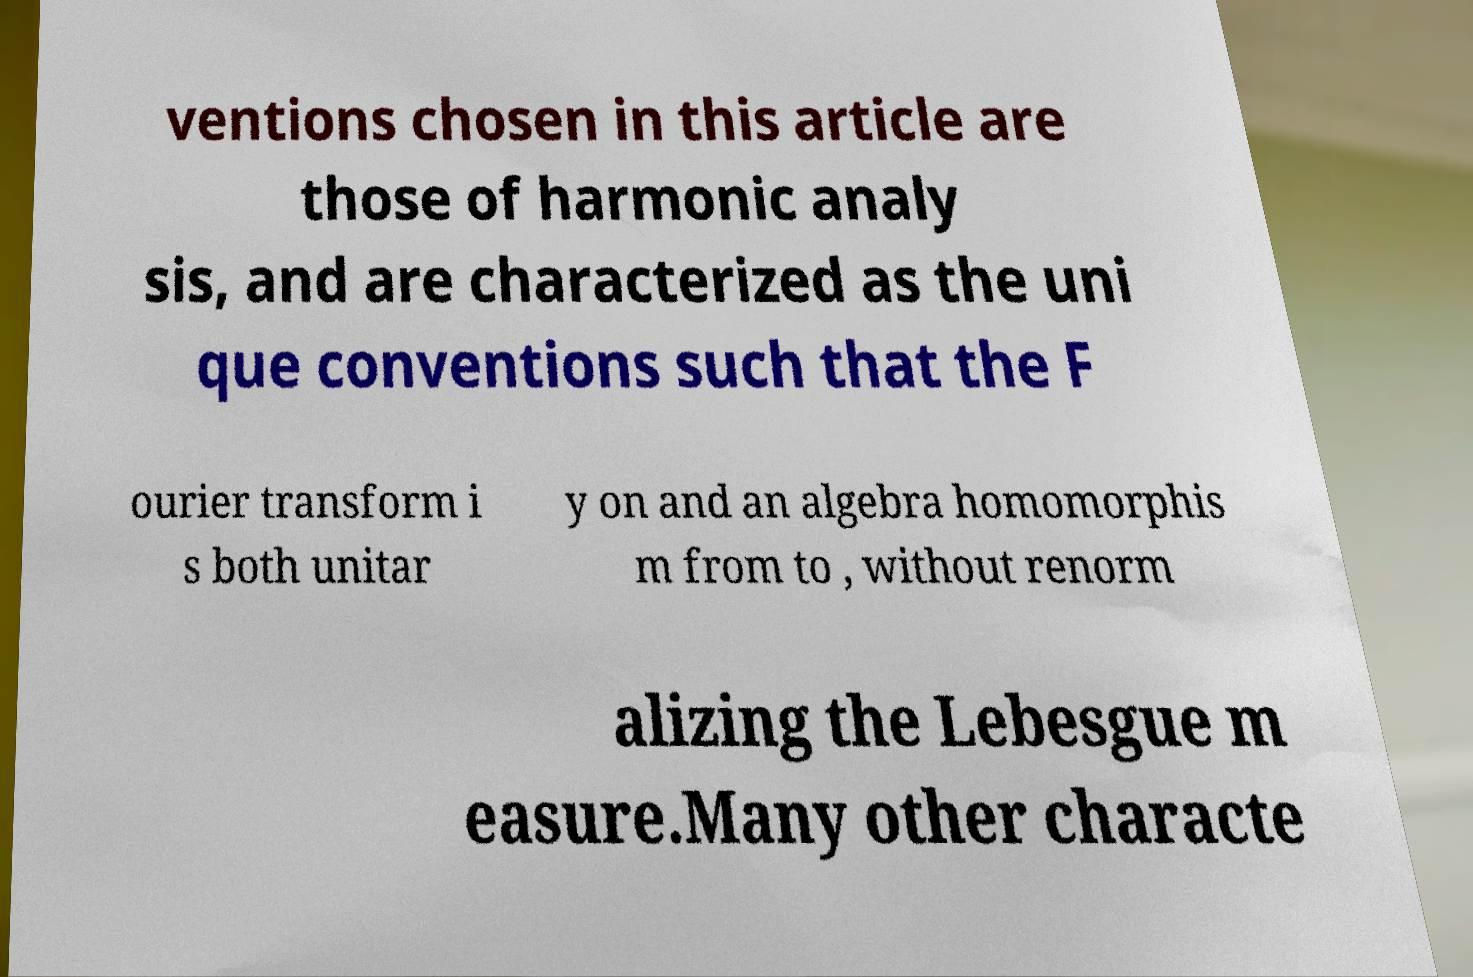Can you read and provide the text displayed in the image?This photo seems to have some interesting text. Can you extract and type it out for me? ventions chosen in this article are those of harmonic analy sis, and are characterized as the uni que conventions such that the F ourier transform i s both unitar y on and an algebra homomorphis m from to , without renorm alizing the Lebesgue m easure.Many other characte 